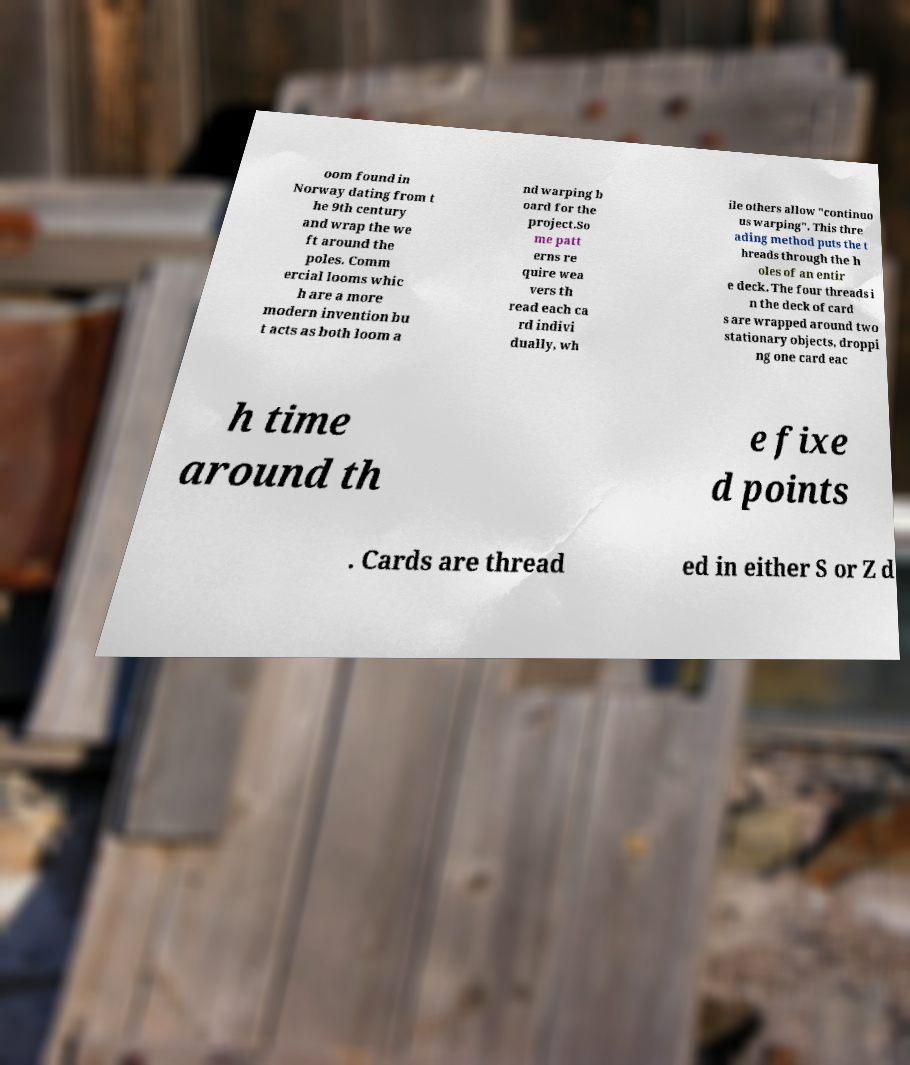What messages or text are displayed in this image? I need them in a readable, typed format. oom found in Norway dating from t he 9th century and wrap the we ft around the poles. Comm ercial looms whic h are a more modern invention bu t acts as both loom a nd warping b oard for the project.So me patt erns re quire wea vers th read each ca rd indivi dually, wh ile others allow "continuo us warping". This thre ading method puts the t hreads through the h oles of an entir e deck. The four threads i n the deck of card s are wrapped around two stationary objects, droppi ng one card eac h time around th e fixe d points . Cards are thread ed in either S or Z d 